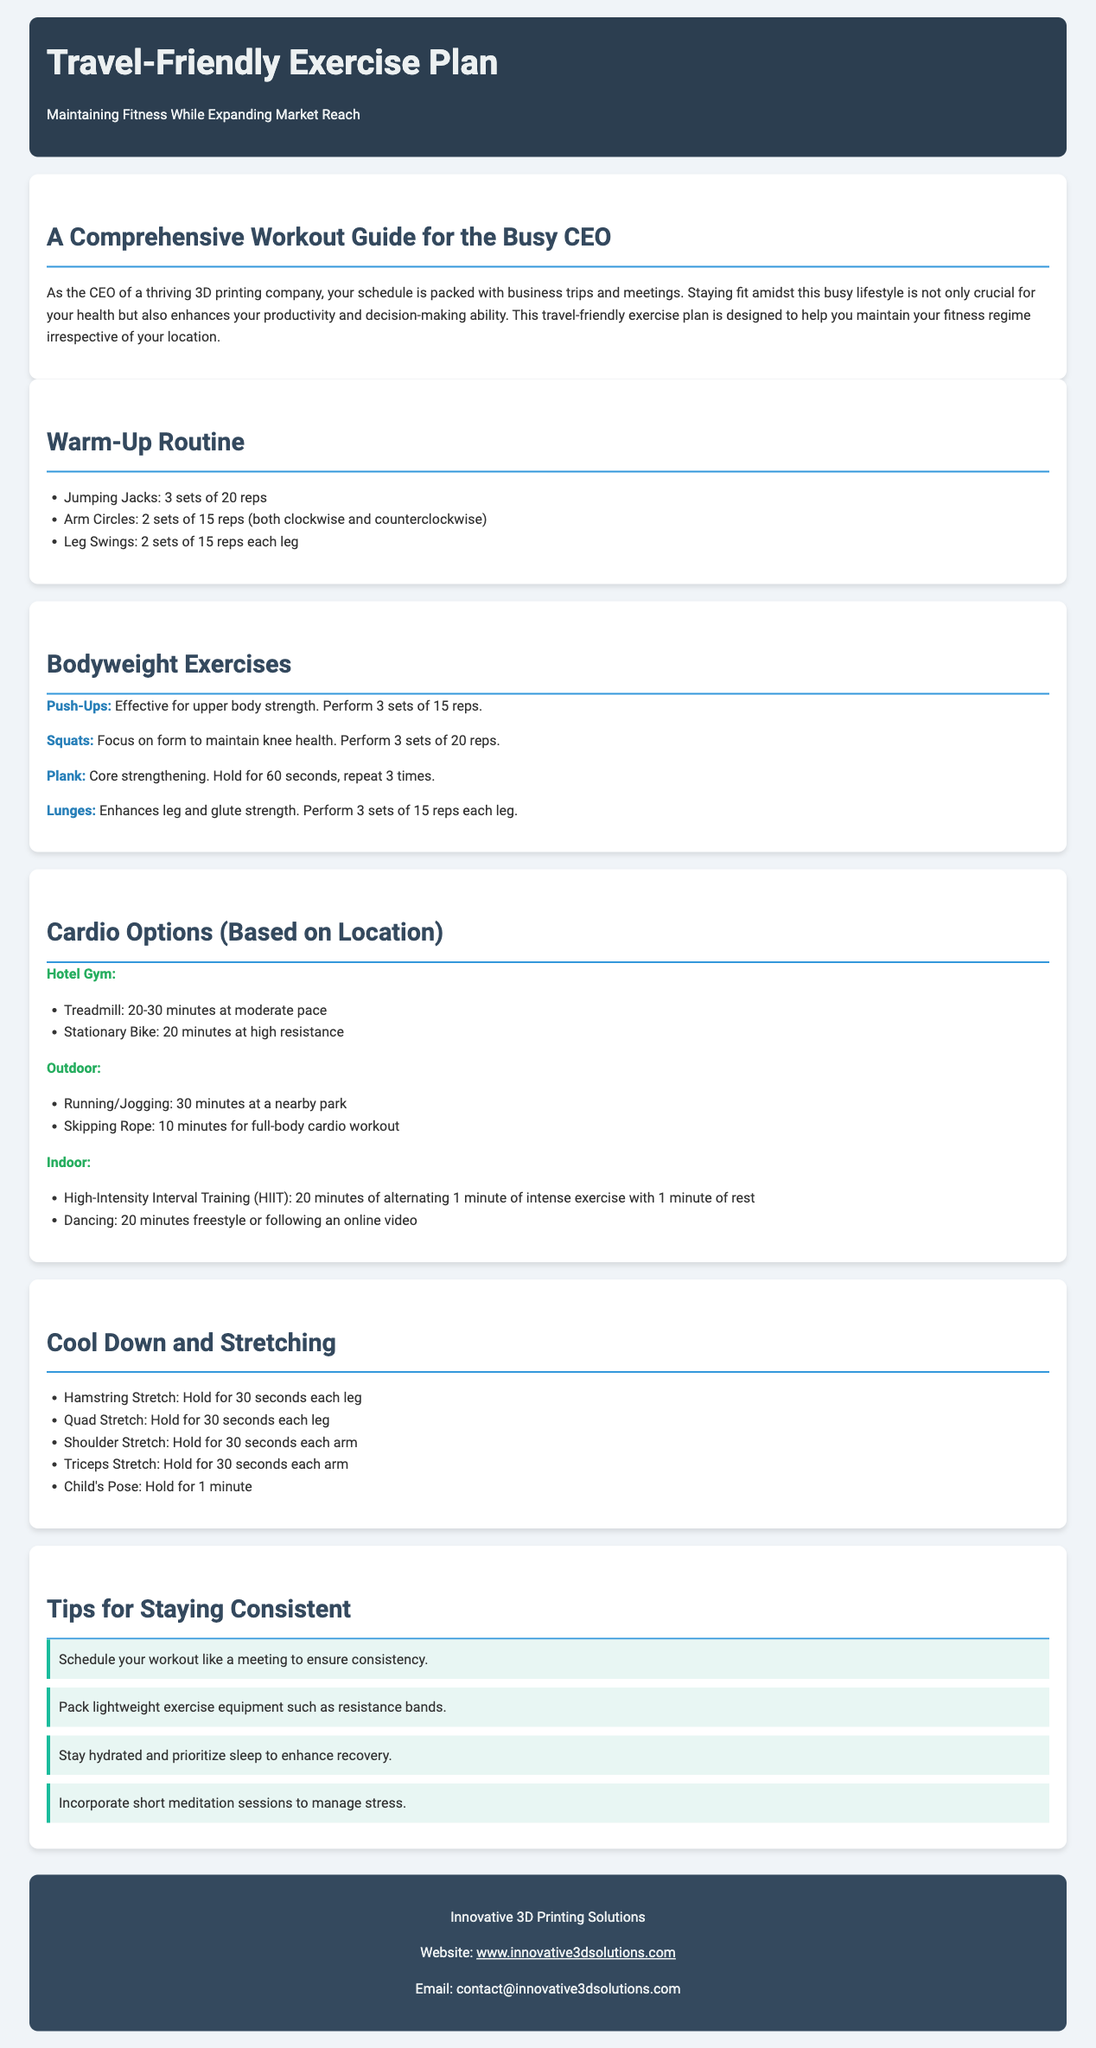What is the title of the document? The title is the main heading found at the top of the document, indicating the subject matter.
Answer: Travel-Friendly Exercise Plan How long should the Plank be held? The duration for holding a Plank is stated as part of the bodyweight exercises section.
Answer: 60 seconds What is a recommended warm-up exercise? This question focuses on finding one of the warm-up exercises listed.
Answer: Jumping Jacks How many sets of Squats are recommended? This question seeks the specified number of sets for a particular exercise mentioned in the bodyweight exercises section.
Answer: 3 sets What is one tip for staying consistent with workouts? This question aims to identify a specific piece of advice given in the tips section of the document.
Answer: Schedule your workout like a meeting Which cardio option is suggested for an outdoor location? This question checks for the recommended cardio activity that can be done outdoors.
Answer: Running/Jogging What is the duration for High-Intensity Interval Training? This question targets the specific timeframe indicated for a cardio option within the document.
Answer: 20 minutes How many reps are suggested for Push-Ups? This question asks for the numeric recommendation stated for the Push-Ups exercise.
Answer: 15 reps 